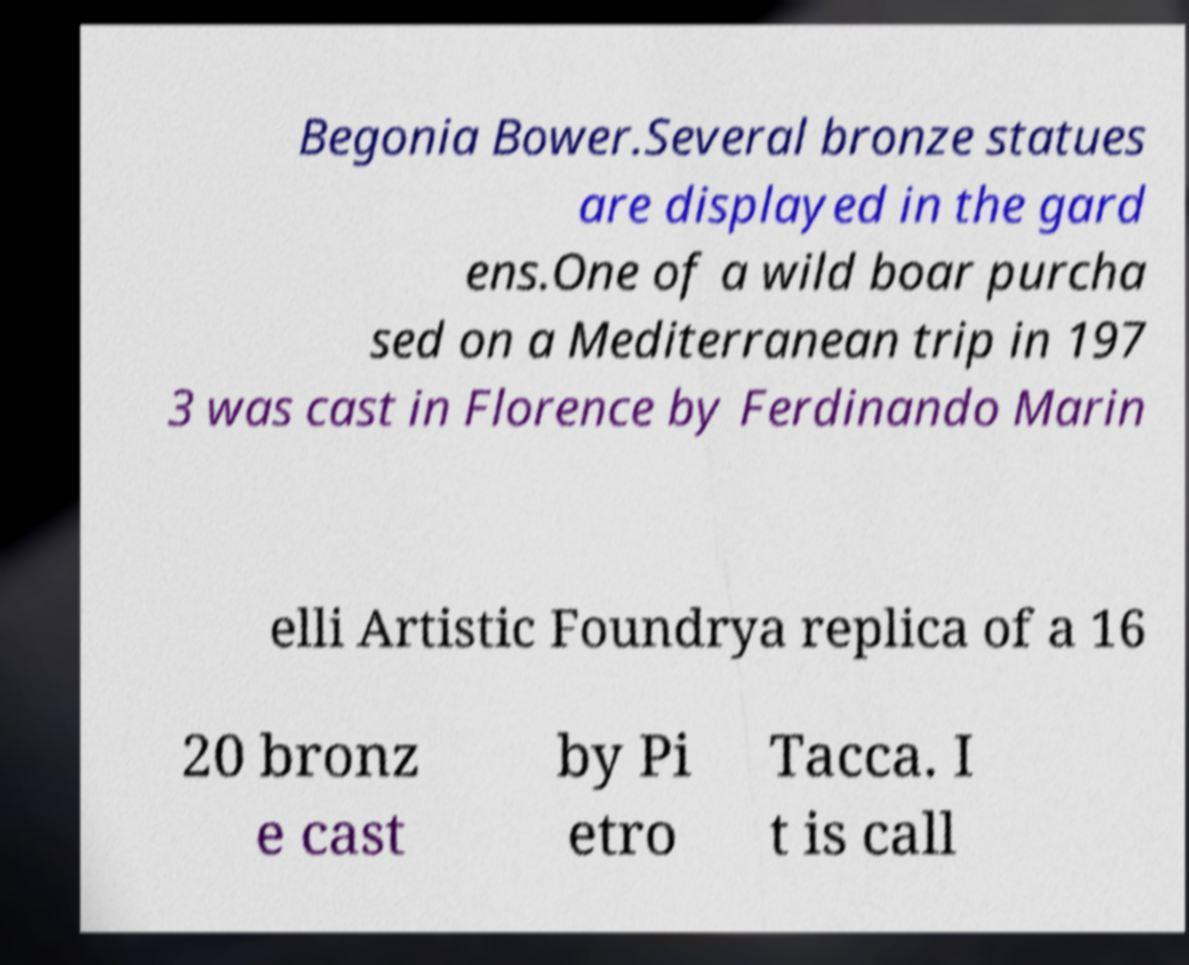There's text embedded in this image that I need extracted. Can you transcribe it verbatim? Begonia Bower.Several bronze statues are displayed in the gard ens.One of a wild boar purcha sed on a Mediterranean trip in 197 3 was cast in Florence by Ferdinando Marin elli Artistic Foundrya replica of a 16 20 bronz e cast by Pi etro Tacca. I t is call 